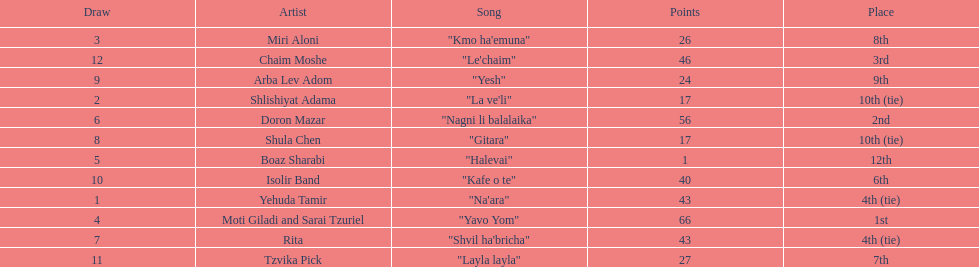Compare draws, which had the least amount of points? Boaz Sharabi. 